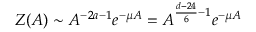<formula> <loc_0><loc_0><loc_500><loc_500>Z ( A ) \sim A ^ { - 2 a - 1 } e ^ { - \mu A } = A ^ { \frac { d - 2 4 } { 6 } - 1 } e ^ { - \mu A }</formula> 